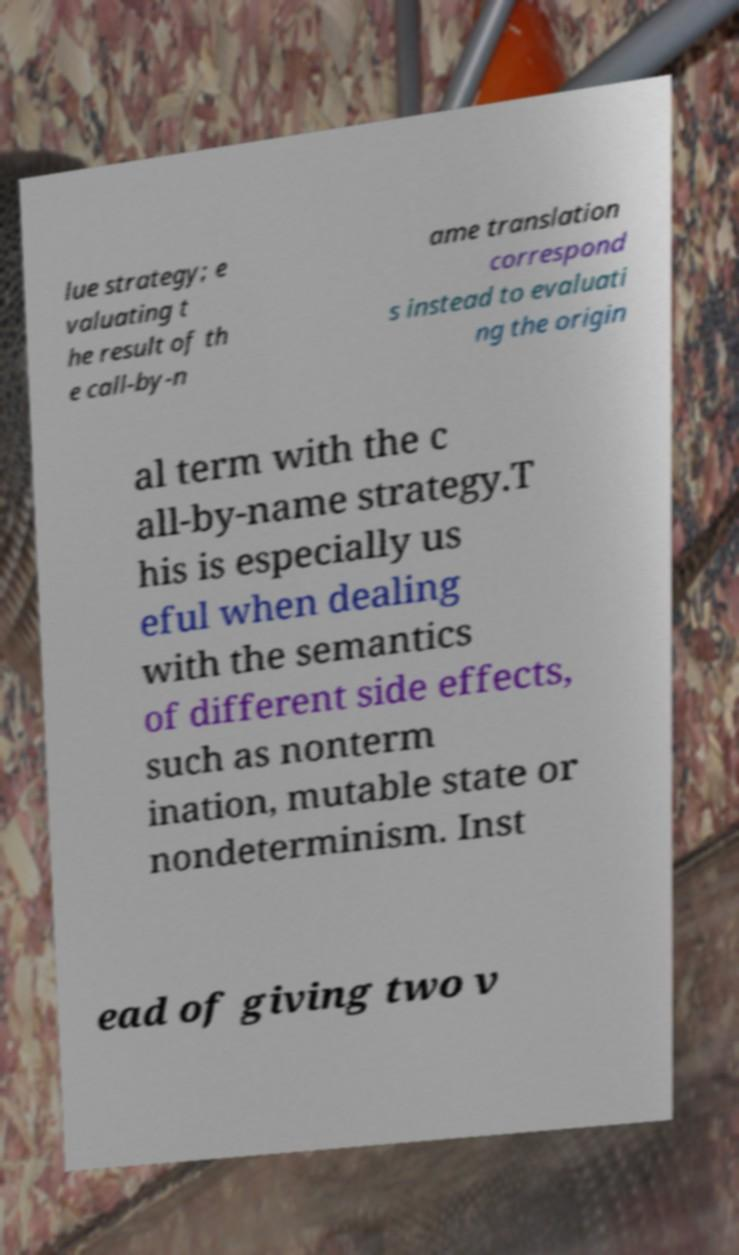Could you extract and type out the text from this image? lue strategy; e valuating t he result of th e call-by-n ame translation correspond s instead to evaluati ng the origin al term with the c all-by-name strategy.T his is especially us eful when dealing with the semantics of different side effects, such as nonterm ination, mutable state or nondeterminism. Inst ead of giving two v 